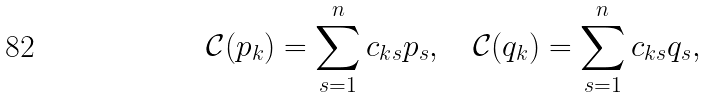<formula> <loc_0><loc_0><loc_500><loc_500>\mathcal { C } ( p _ { k } ) = \sum _ { s = 1 } ^ { n } c _ { k s } p _ { s } , \quad \mathcal { C } ( q _ { k } ) = \sum _ { s = 1 } ^ { n } c _ { k s } q _ { s } ,</formula> 